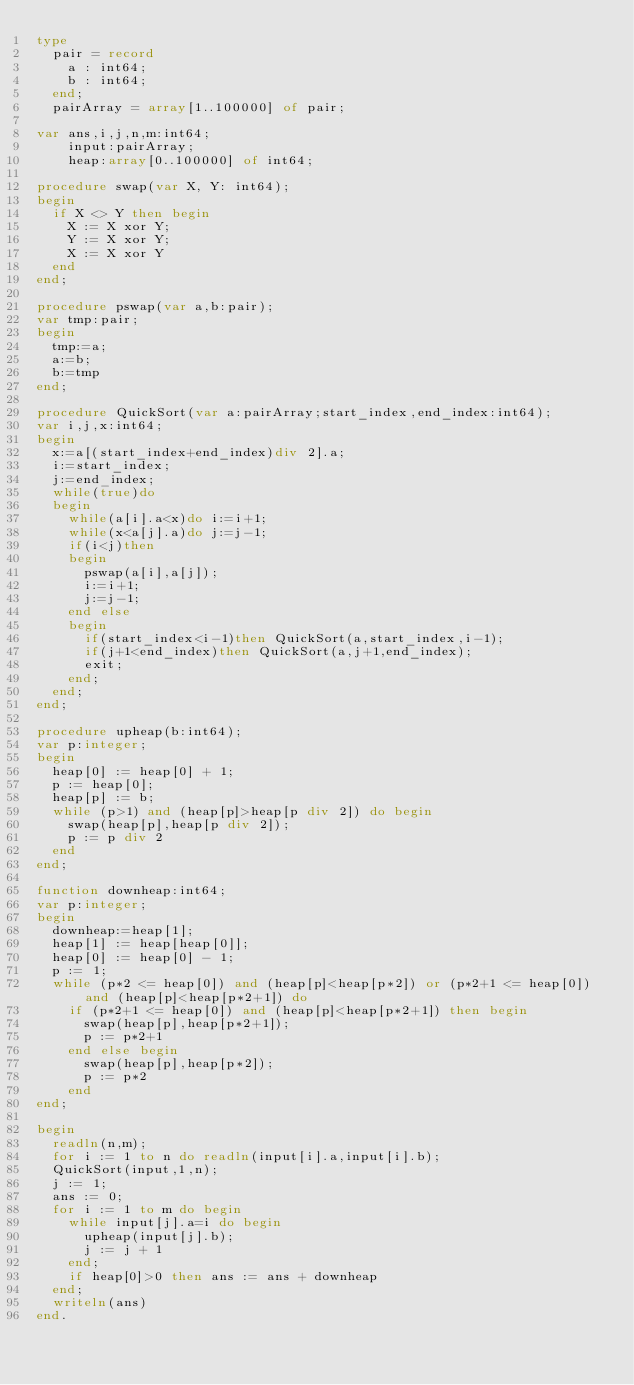<code> <loc_0><loc_0><loc_500><loc_500><_Pascal_>type
  pair = record
    a : int64;
    b : int64;
  end;
	pairArray = array[1..100000] of pair;

var ans,i,j,n,m:int64;
    input:pairArray;
    heap:array[0..100000] of int64;

procedure swap(var X, Y: int64);
begin
	if X <> Y then begin
		X := X xor Y;
		Y := X xor Y;
		X := X xor Y
	end
end;

procedure	pswap(var a,b:pair);
var tmp:pair;
begin
	tmp:=a;
	a:=b;
	b:=tmp
end;

procedure QuickSort(var a:pairArray;start_index,end_index:int64);
var i,j,x:int64;
begin
	x:=a[(start_index+end_index)div 2].a;
	i:=start_index;
	j:=end_index;
	while(true)do
	begin
		while(a[i].a<x)do i:=i+1;
		while(x<a[j].a)do j:=j-1;
		if(i<j)then
		begin
			pswap(a[i],a[j]);
			i:=i+1;
			j:=j-1;
		end else
		begin
			if(start_index<i-1)then QuickSort(a,start_index,i-1);
			if(j+1<end_index)then QuickSort(a,j+1,end_index);
			exit;
		end;
	end;
end;

procedure upheap(b:int64);
var p:integer;
begin
  heap[0] := heap[0] + 1;
  p := heap[0];
  heap[p] := b;
  while (p>1) and (heap[p]>heap[p div 2]) do begin
    swap(heap[p],heap[p div 2]);
    p := p div 2
  end
end;

function downheap:int64;
var p:integer;
begin
  downheap:=heap[1];
  heap[1] := heap[heap[0]];
  heap[0] := heap[0] - 1;
  p := 1;
  while (p*2 <= heap[0]) and (heap[p]<heap[p*2]) or (p*2+1 <= heap[0]) and (heap[p]<heap[p*2+1]) do
    if (p*2+1 <= heap[0]) and (heap[p]<heap[p*2+1]) then begin
      swap(heap[p],heap[p*2+1]);
      p := p*2+1
    end else begin
      swap(heap[p],heap[p*2]);
      p := p*2
    end
end;

begin
  readln(n,m);
  for i := 1 to n do readln(input[i].a,input[i].b);
  QuickSort(input,1,n);
  j := 1;
  ans := 0;
  for i := 1 to m do begin
    while input[j].a=i do begin
      upheap(input[j].b);
      j := j + 1
    end;
    if heap[0]>0 then ans := ans + downheap
  end;
  writeln(ans)
end.</code> 